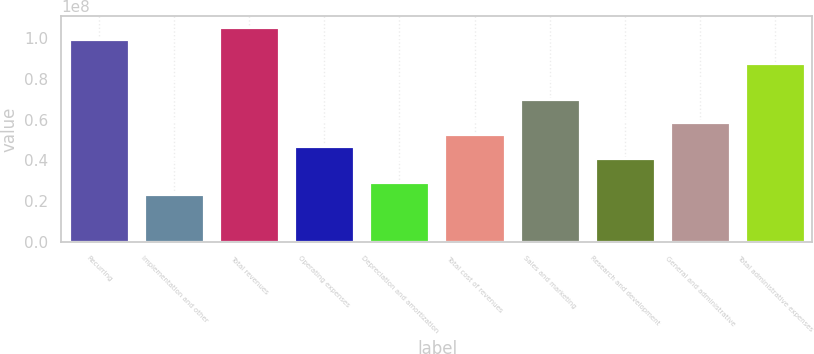<chart> <loc_0><loc_0><loc_500><loc_500><bar_chart><fcel>Recurring<fcel>Implementation and other<fcel>Total revenues<fcel>Operating expenses<fcel>Depreciation and amortization<fcel>Total cost of revenues<fcel>Sales and marketing<fcel>Research and development<fcel>General and administrative<fcel>Total administrative expenses<nl><fcel>9.95902e+07<fcel>2.3433e+07<fcel>1.05448e+08<fcel>4.6866e+07<fcel>2.92912e+07<fcel>5.27242e+07<fcel>7.0299e+07<fcel>4.10077e+07<fcel>5.85825e+07<fcel>8.78737e+07<nl></chart> 